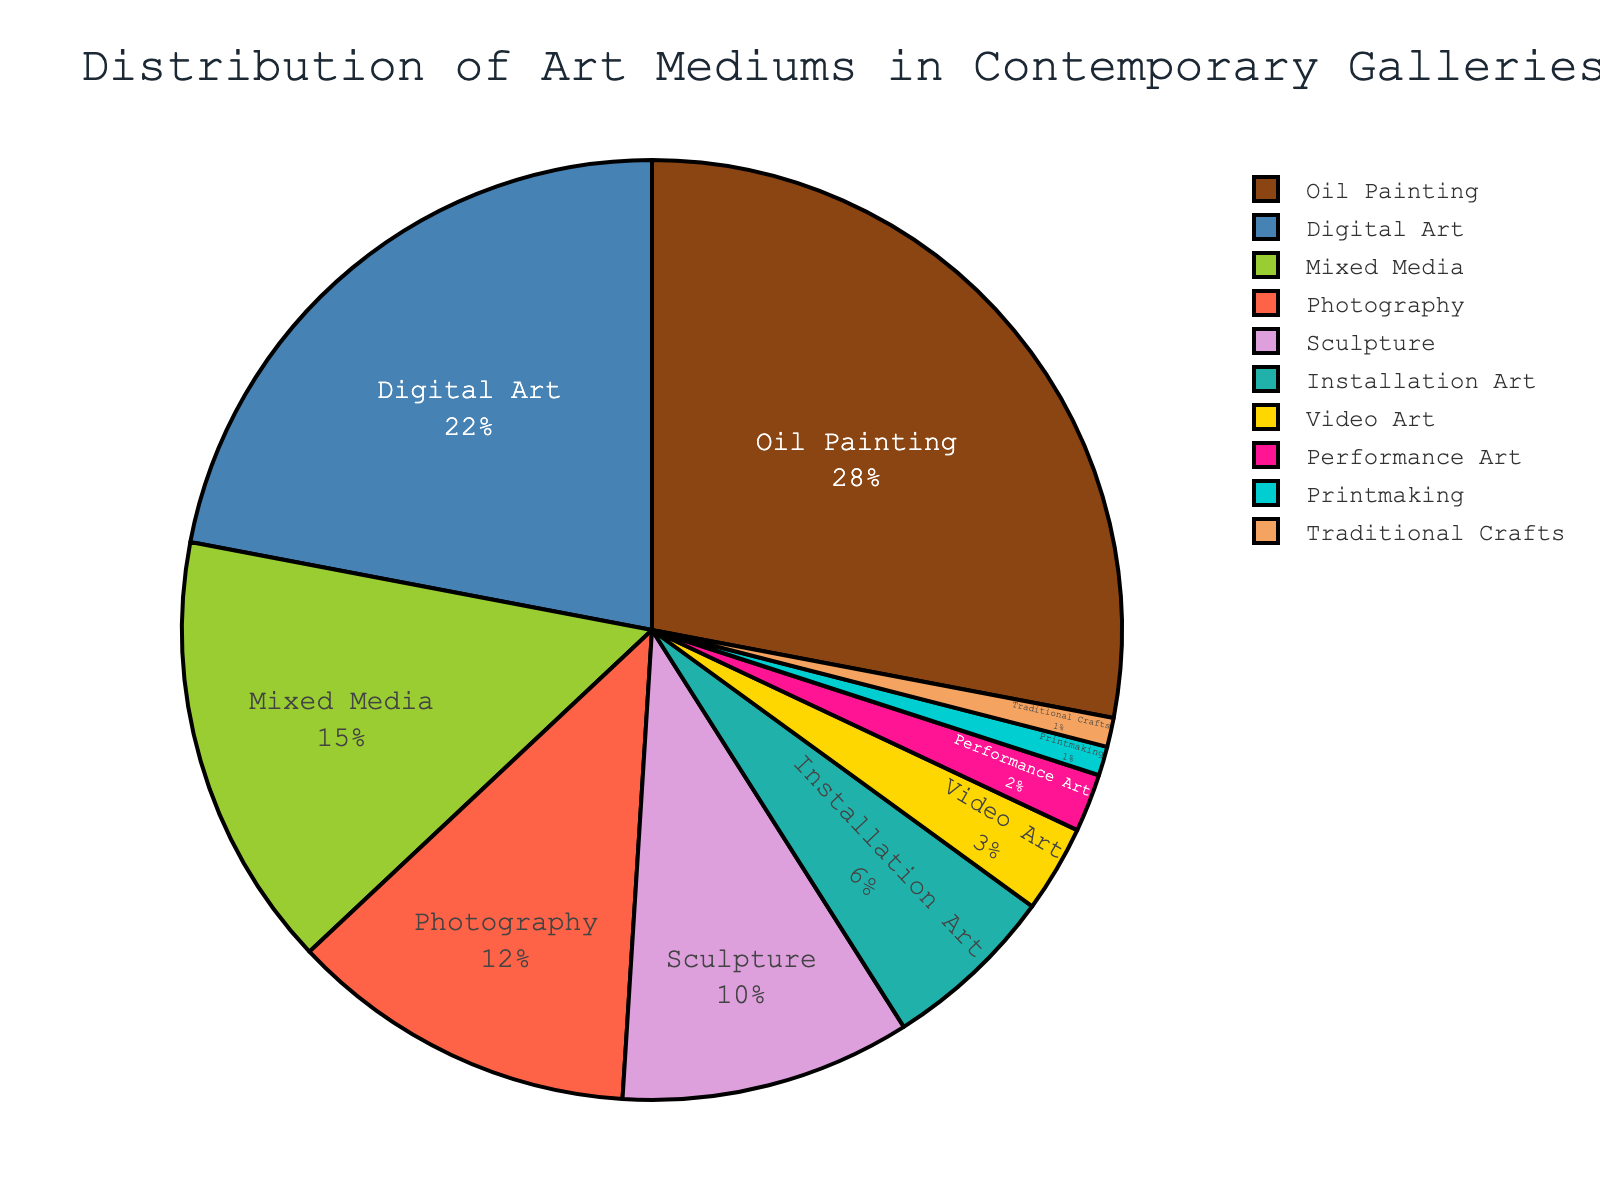How many percentage points higher is the distribution of Oil Painting than Sculpture? Oil Painting has a distribution of 28% and Sculpture has 10%. To find the difference, subtract the percentage for Sculpture from that of Oil Painting: 28 - 10 = 18.
Answer: 18 What is the combined percentage of Digital Art and Photography? The distribution of Digital Art is 22%, and Photography is 12%. Adding these two percentages gives us: 22 + 12 = 34.
Answer: 34 Which medium has the lowest distribution and what is its percentage? From the figure, Traditional Crafts has the lowest distribution at 1%.
Answer: Traditional Crafts, 1% How much more prevalent is Mixed Media compared to Performance Art? The percentage for Mixed Media is 15%, and for Performance Art, it is 2%. The difference is found by subtracting: 15 - 2 = 13.
Answer: 13 What is the percentage distribution of all mediums excluding Oil Painting and Digital Art combined? The sum of all percentages excluding Oil Painting (28%) and Digital Art (22%) is calculated as follows: 15 + 12 + 10 + 6 + 3 + 2 + 1 + 1. Summing these gives: 15 + 12 + 10 + 6 + 3 + 2 + 1 + 1 = 50.
Answer: 50 Is Installation Art's distribution greater than that of Video Art? By how much? Installation Art has a distribution of 6%, and Video Art has 3%. To find how much greater Installation Art is, subtract Video Art's percentage from Installation Art's: 6 - 3 = 3.
Answer: Yes, by 3 Which medium is represented by the largest section of the pie, and what is its percentage? The medium represented by the largest section of the pie is Oil Painting with 28%.
Answer: Oil Painting, 28% How does the distribution of Photography compare to Sculpture? Photography has a distribution of 12%, and Sculpture has 10%. Since 12% is greater than 10%, Photography is more prevalent by 2 percentage points.
Answer: Photography is more by 2 Calculate the average percentage distribution of Installation Art, Video Art, and Performance Art. The percentages for Installation Art, Video Art, and Performance Art are 6%, 3%, and 2% respectively. To find the average, sum these values and divide by 3: (6 + 3 + 2) / 3 = 11 / 3 = 3.67.
Answer: 3.67 What is the visual difference between the proportions of Printmaking and Traditional Crafts? Both Printmaking and Traditional Crafts have the same percentage of 1%. Since they are equal, the visual difference in proportions is non-existent.
Answer: No difference 